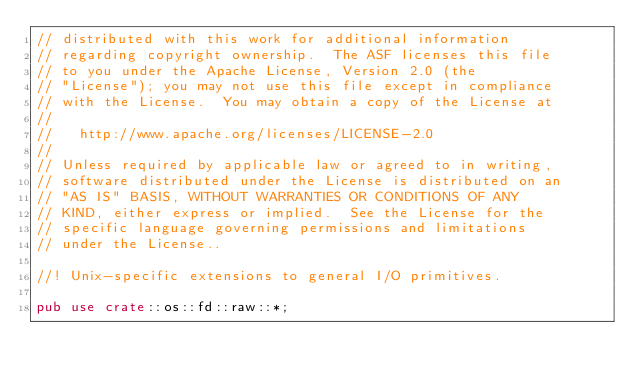Convert code to text. <code><loc_0><loc_0><loc_500><loc_500><_Rust_>// distributed with this work for additional information
// regarding copyright ownership.  The ASF licenses this file
// to you under the Apache License, Version 2.0 (the
// "License"); you may not use this file except in compliance
// with the License.  You may obtain a copy of the License at
//
//   http://www.apache.org/licenses/LICENSE-2.0
//
// Unless required by applicable law or agreed to in writing,
// software distributed under the License is distributed on an
// "AS IS" BASIS, WITHOUT WARRANTIES OR CONDITIONS OF ANY
// KIND, either express or implied.  See the License for the
// specific language governing permissions and limitations
// under the License..

//! Unix-specific extensions to general I/O primitives.

pub use crate::os::fd::raw::*;
</code> 